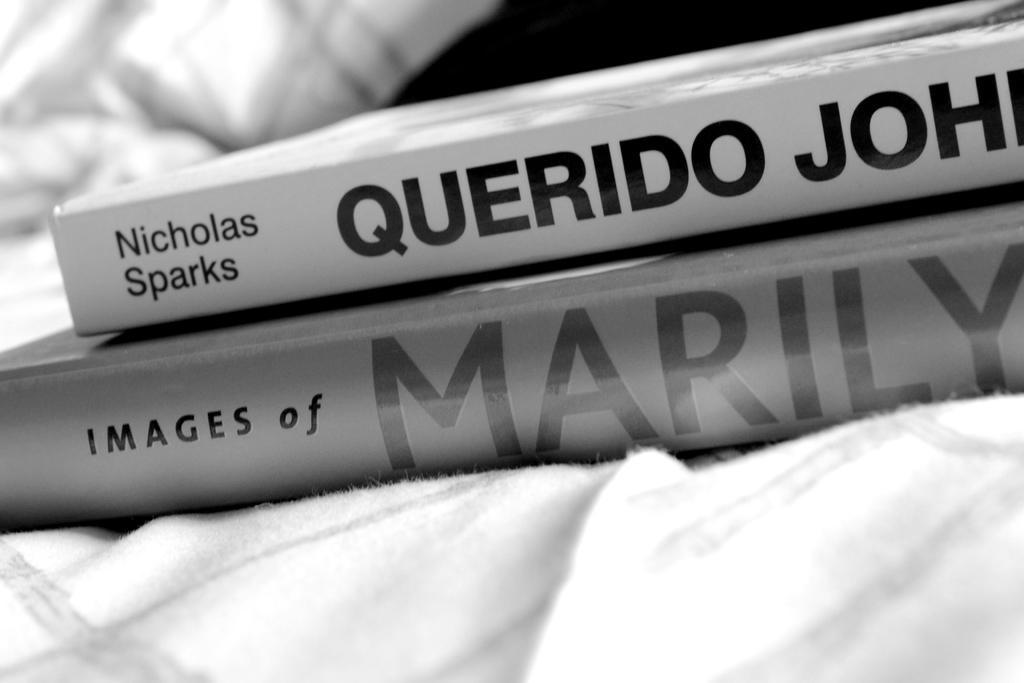Describe this image in one or two sentences. As we can see in the image there are books and white color cloth. The background is blurred. 